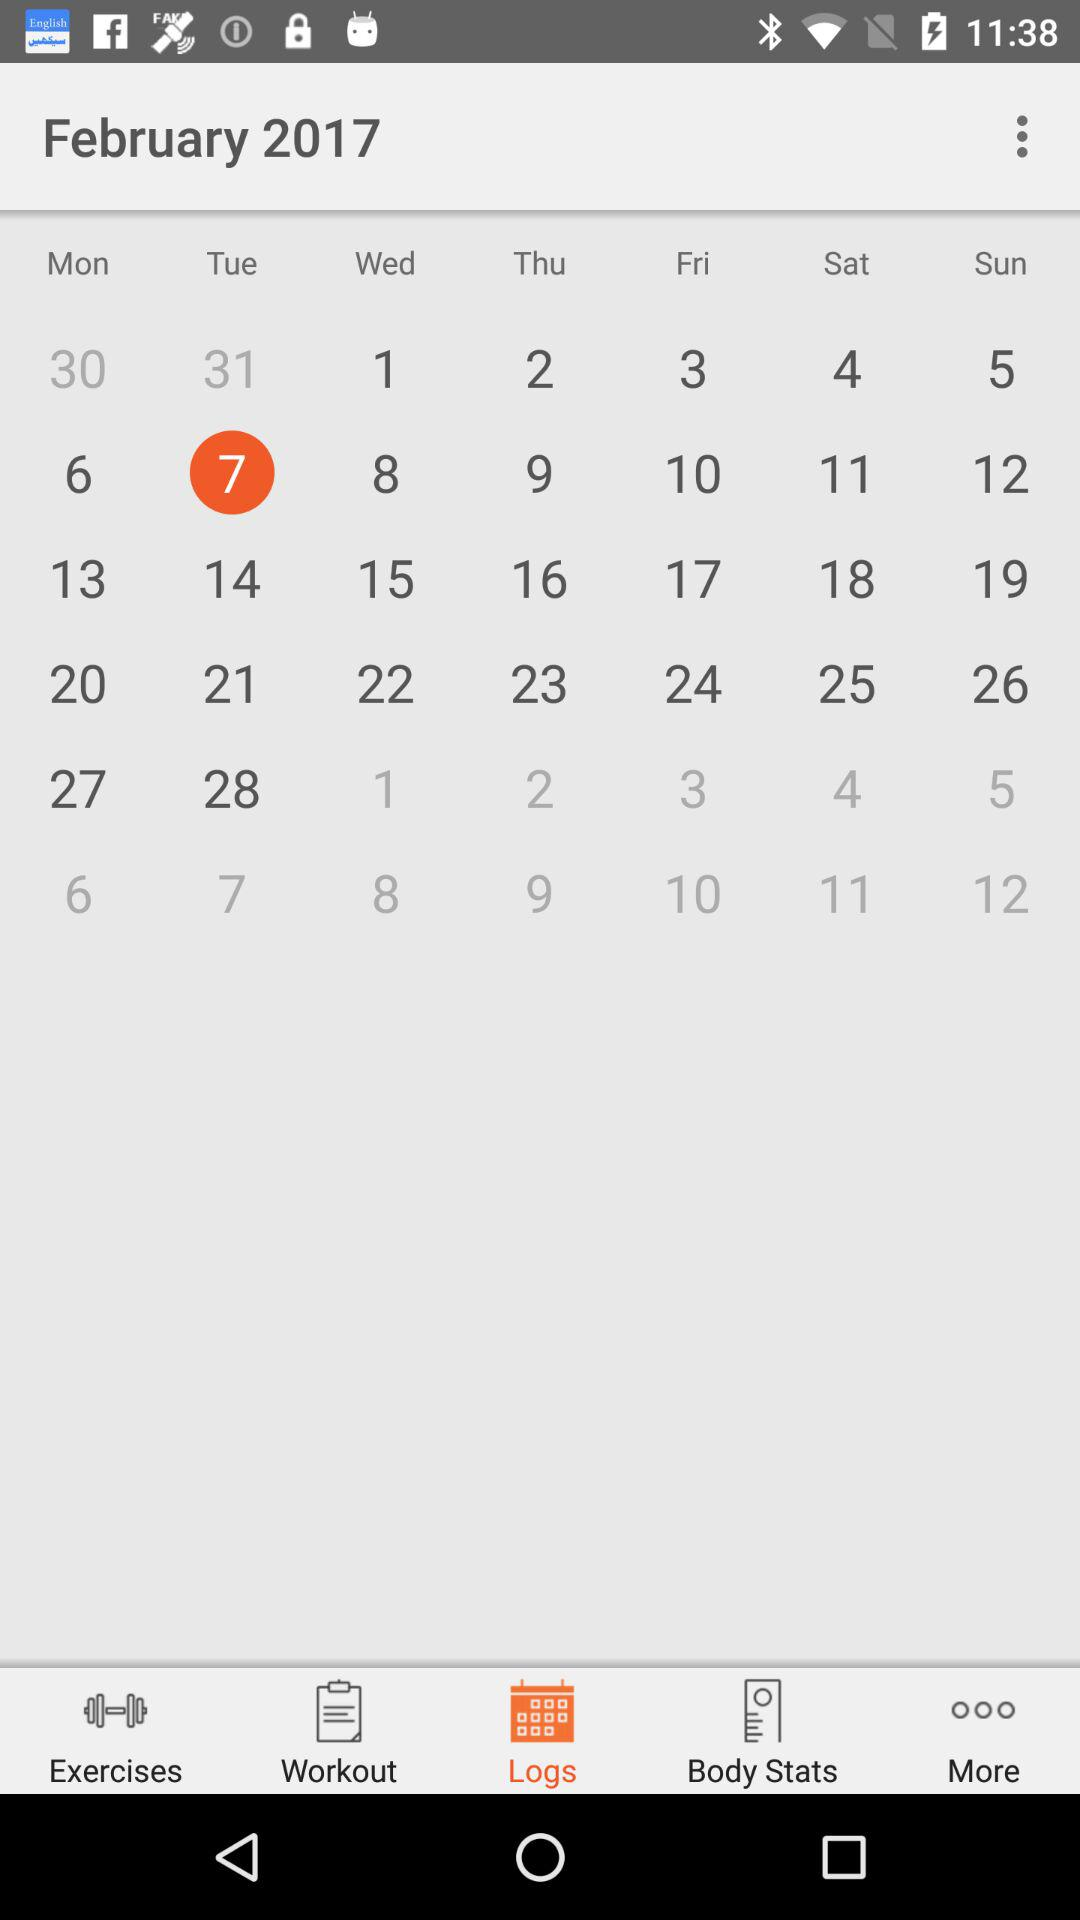Which tab is currently selected? The selected tab is "Logs". 